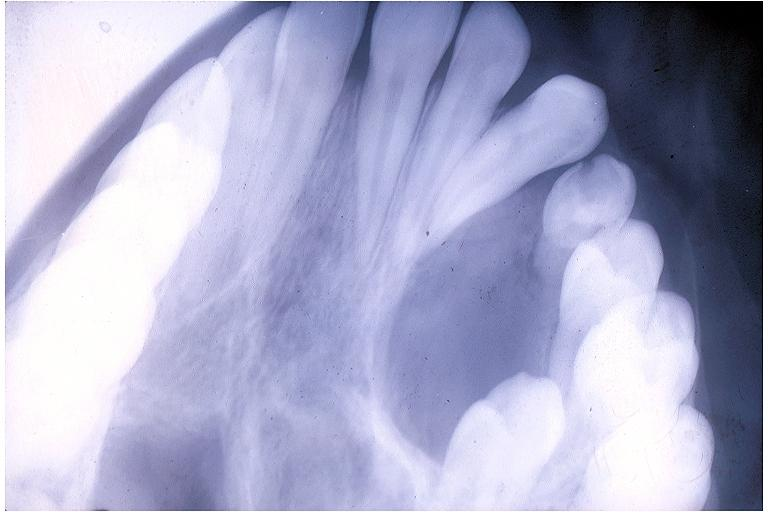s arcus senilis present?
Answer the question using a single word or phrase. No 